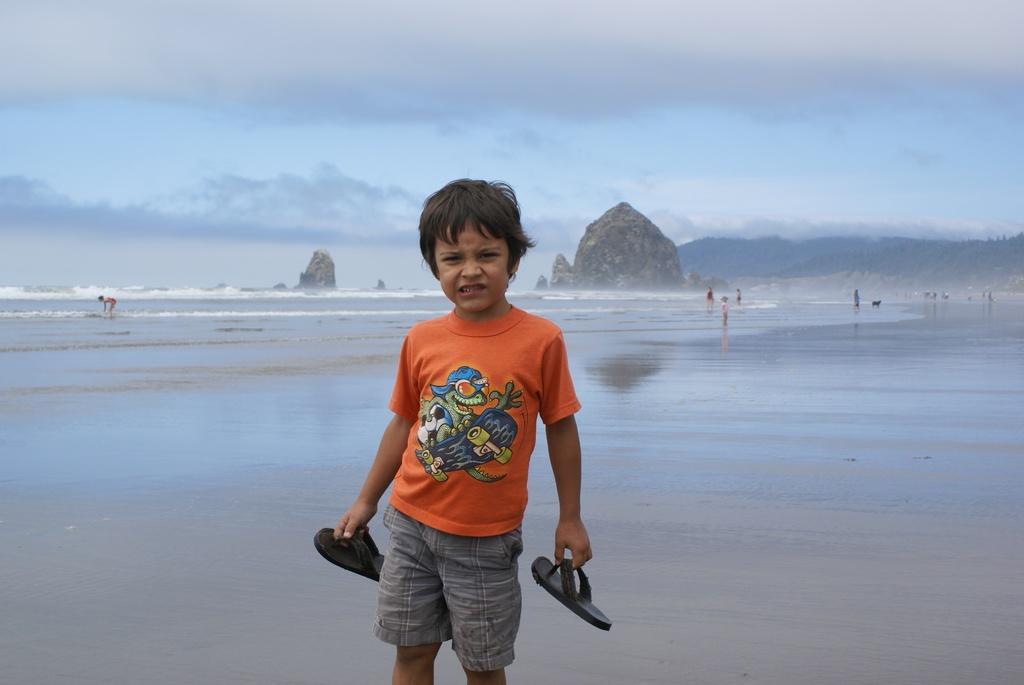Please provide a concise description of this image. In this image we can see a boy wearing an orange t shirt is holding the slippers in his hand. In the background, we can see water, mountains and the cloudy sky. 